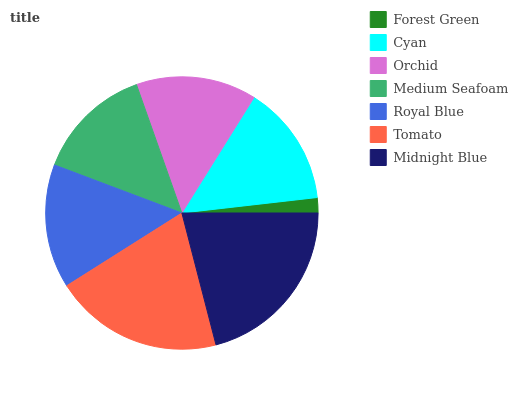Is Forest Green the minimum?
Answer yes or no. Yes. Is Midnight Blue the maximum?
Answer yes or no. Yes. Is Cyan the minimum?
Answer yes or no. No. Is Cyan the maximum?
Answer yes or no. No. Is Cyan greater than Forest Green?
Answer yes or no. Yes. Is Forest Green less than Cyan?
Answer yes or no. Yes. Is Forest Green greater than Cyan?
Answer yes or no. No. Is Cyan less than Forest Green?
Answer yes or no. No. Is Cyan the high median?
Answer yes or no. Yes. Is Cyan the low median?
Answer yes or no. Yes. Is Medium Seafoam the high median?
Answer yes or no. No. Is Orchid the low median?
Answer yes or no. No. 